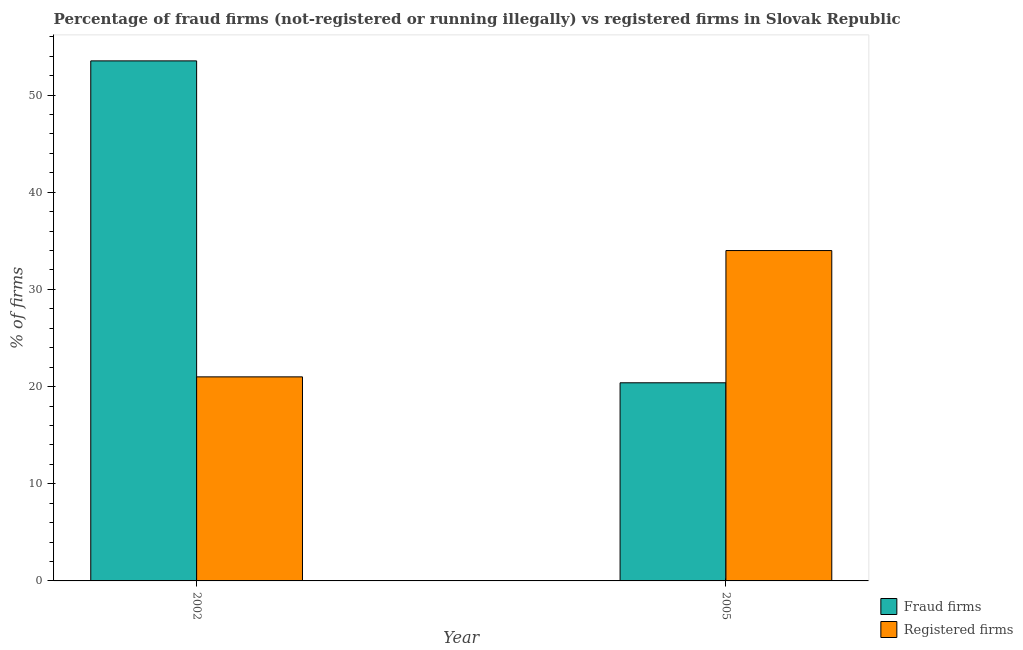How many different coloured bars are there?
Provide a succinct answer. 2. How many groups of bars are there?
Ensure brevity in your answer.  2. Are the number of bars per tick equal to the number of legend labels?
Offer a very short reply. Yes. How many bars are there on the 2nd tick from the left?
Provide a short and direct response. 2. How many bars are there on the 1st tick from the right?
Provide a short and direct response. 2. What is the percentage of fraud firms in 2002?
Give a very brief answer. 53.52. Across all years, what is the maximum percentage of fraud firms?
Give a very brief answer. 53.52. Across all years, what is the minimum percentage of fraud firms?
Provide a short and direct response. 20.39. In which year was the percentage of fraud firms maximum?
Offer a very short reply. 2002. In which year was the percentage of fraud firms minimum?
Provide a short and direct response. 2005. What is the total percentage of fraud firms in the graph?
Give a very brief answer. 73.91. What is the difference between the percentage of fraud firms in 2002 and that in 2005?
Offer a very short reply. 33.13. What is the difference between the percentage of registered firms in 2005 and the percentage of fraud firms in 2002?
Give a very brief answer. 13. What is the average percentage of registered firms per year?
Keep it short and to the point. 27.5. In the year 2002, what is the difference between the percentage of fraud firms and percentage of registered firms?
Provide a succinct answer. 0. What is the ratio of the percentage of fraud firms in 2002 to that in 2005?
Offer a very short reply. 2.62. Is the percentage of registered firms in 2002 less than that in 2005?
Provide a succinct answer. Yes. In how many years, is the percentage of registered firms greater than the average percentage of registered firms taken over all years?
Provide a succinct answer. 1. What does the 2nd bar from the left in 2005 represents?
Offer a very short reply. Registered firms. What does the 1st bar from the right in 2002 represents?
Make the answer very short. Registered firms. Are all the bars in the graph horizontal?
Your answer should be compact. No. How many years are there in the graph?
Your answer should be very brief. 2. Does the graph contain any zero values?
Ensure brevity in your answer.  No. Does the graph contain grids?
Your answer should be very brief. No. Where does the legend appear in the graph?
Offer a very short reply. Bottom right. How are the legend labels stacked?
Offer a terse response. Vertical. What is the title of the graph?
Provide a short and direct response. Percentage of fraud firms (not-registered or running illegally) vs registered firms in Slovak Republic. Does "Services" appear as one of the legend labels in the graph?
Your response must be concise. No. What is the label or title of the X-axis?
Make the answer very short. Year. What is the label or title of the Y-axis?
Keep it short and to the point. % of firms. What is the % of firms of Fraud firms in 2002?
Ensure brevity in your answer.  53.52. What is the % of firms in Fraud firms in 2005?
Your answer should be compact. 20.39. What is the % of firms of Registered firms in 2005?
Offer a very short reply. 34. Across all years, what is the maximum % of firms of Fraud firms?
Keep it short and to the point. 53.52. Across all years, what is the maximum % of firms of Registered firms?
Your answer should be very brief. 34. Across all years, what is the minimum % of firms in Fraud firms?
Provide a short and direct response. 20.39. Across all years, what is the minimum % of firms in Registered firms?
Provide a short and direct response. 21. What is the total % of firms of Fraud firms in the graph?
Make the answer very short. 73.91. What is the difference between the % of firms of Fraud firms in 2002 and that in 2005?
Offer a terse response. 33.13. What is the difference between the % of firms of Registered firms in 2002 and that in 2005?
Provide a succinct answer. -13. What is the difference between the % of firms in Fraud firms in 2002 and the % of firms in Registered firms in 2005?
Provide a succinct answer. 19.52. What is the average % of firms of Fraud firms per year?
Your answer should be very brief. 36.95. In the year 2002, what is the difference between the % of firms of Fraud firms and % of firms of Registered firms?
Ensure brevity in your answer.  32.52. In the year 2005, what is the difference between the % of firms in Fraud firms and % of firms in Registered firms?
Offer a very short reply. -13.61. What is the ratio of the % of firms in Fraud firms in 2002 to that in 2005?
Make the answer very short. 2.62. What is the ratio of the % of firms of Registered firms in 2002 to that in 2005?
Your response must be concise. 0.62. What is the difference between the highest and the second highest % of firms in Fraud firms?
Make the answer very short. 33.13. What is the difference between the highest and the second highest % of firms in Registered firms?
Your response must be concise. 13. What is the difference between the highest and the lowest % of firms of Fraud firms?
Your answer should be very brief. 33.13. What is the difference between the highest and the lowest % of firms in Registered firms?
Your answer should be very brief. 13. 